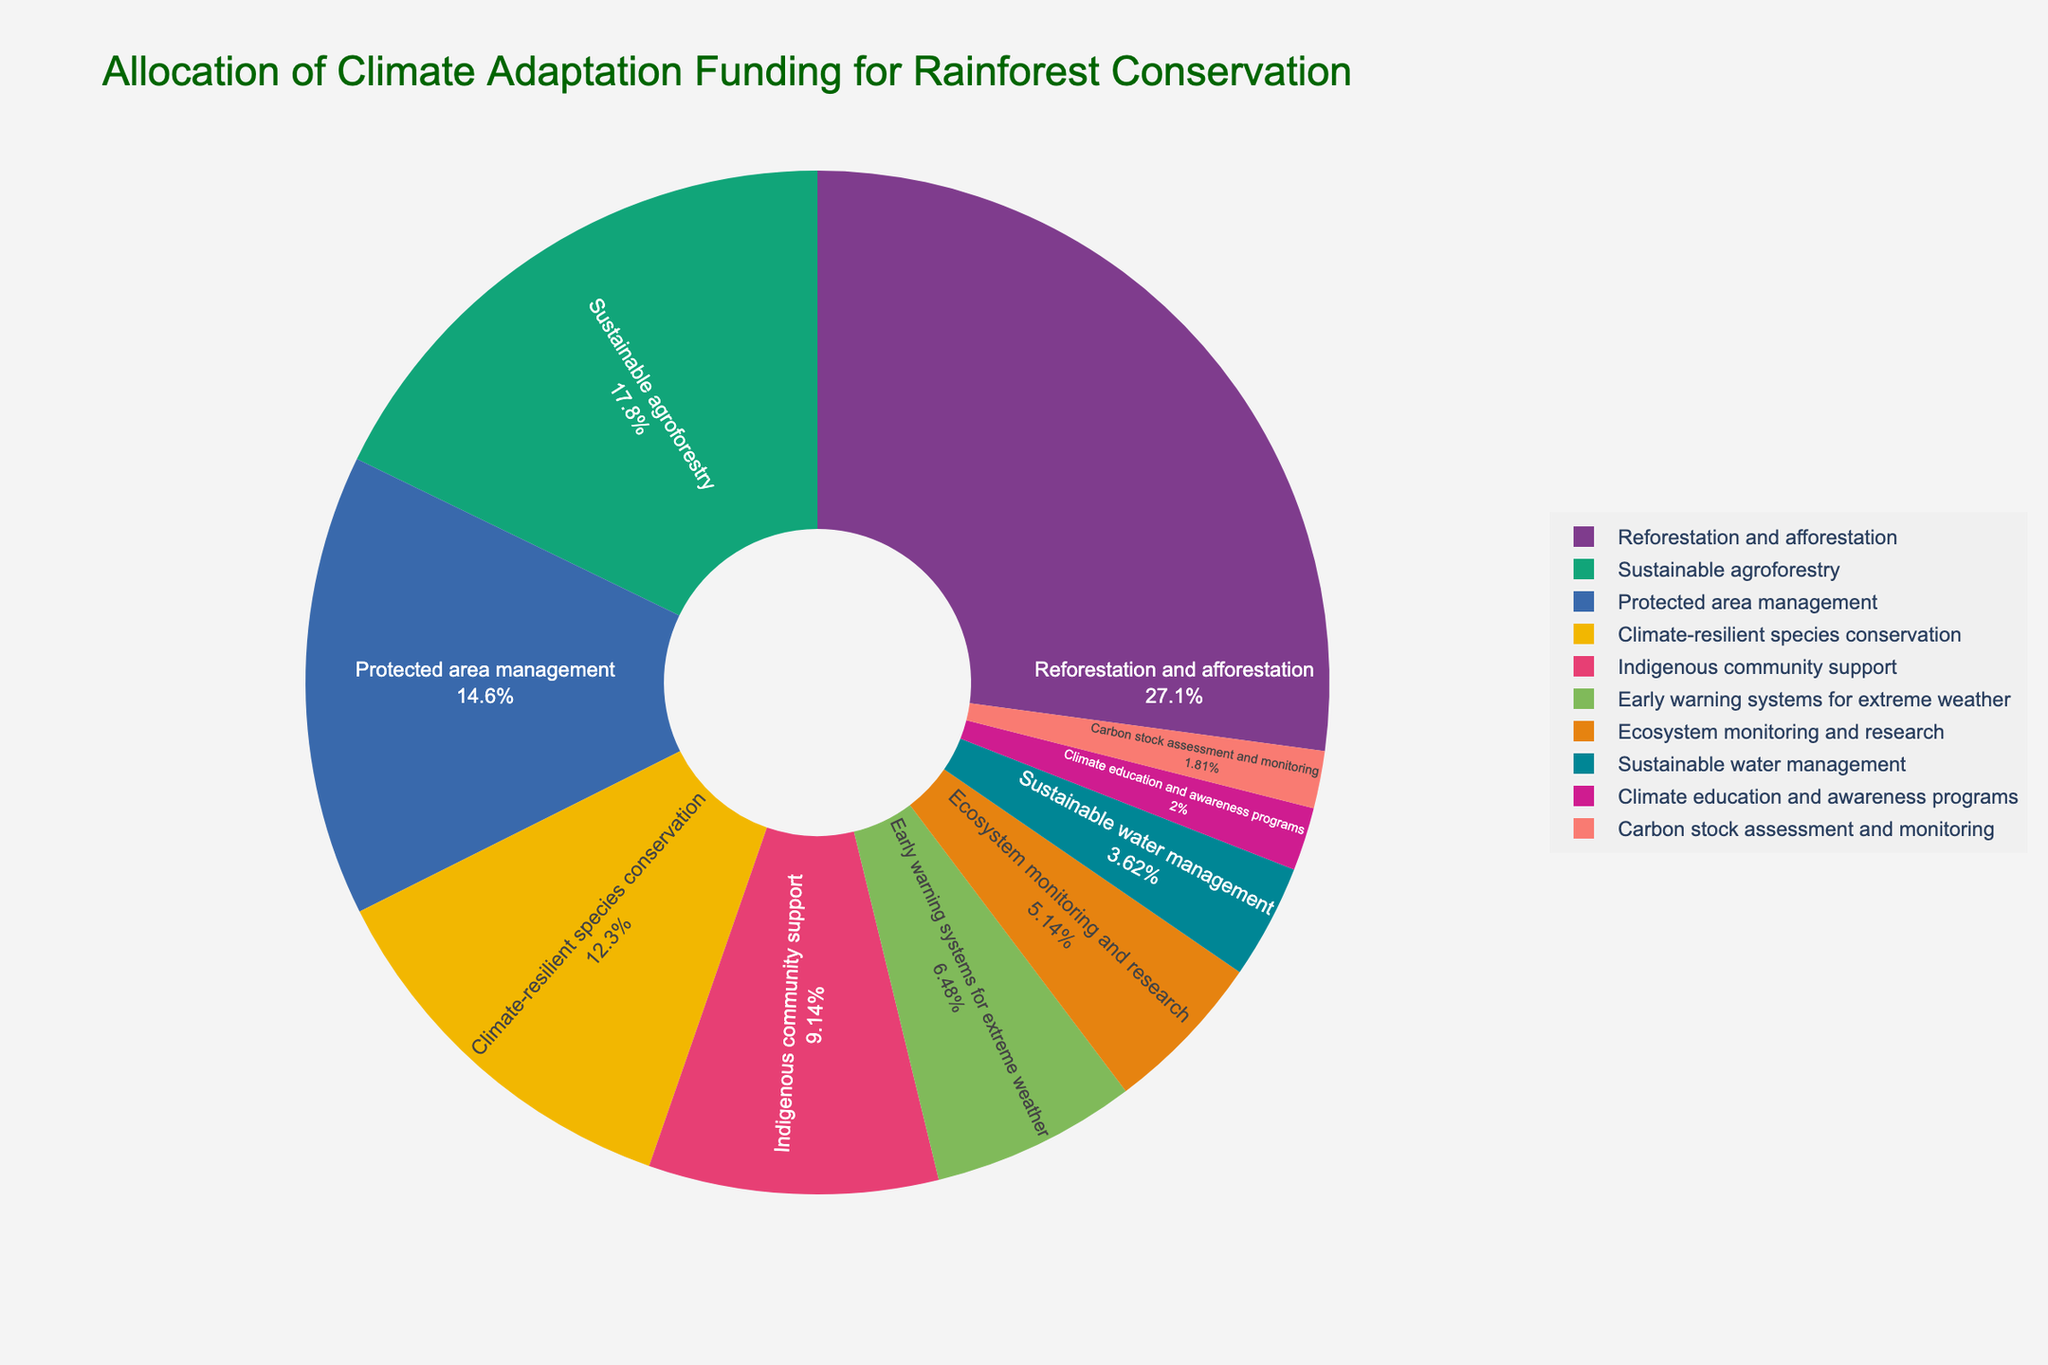How much funding is allocated to reforestation and afforestation compared to sustainable agroforestry? Reforestation and afforestation has an allocation of 28.5%, while sustainable agroforestry has 18.7%. The difference between them is 28.5% - 18.7% = 9.8%.
Answer: 9.8% What is the total funding allocated to protected area management, climate-resilient species conservation, and ecosystem monitoring and research combined? Adding the percentages for these strategies: 15.3 (protected area management) + 12.9 (climate-resilient species conservation) + 5.4 (ecosystem monitoring and research) = 33.6%.
Answer: 33.6% Which strategy received the least funding allocation and what is its allocation? Carbon stock assessment and monitoring received the least funding with an allocation of 1.9%.
Answer: Carbon stock assessment and monitoring, 1.9% Are there any strategies that received an equal funding allocation? No strategies have an equal funding allocation; all percentages are unique.
Answer: No What is the average funding allocation percentage for all strategies? Summing all allocations: 28.5 + 18.7 + 15.3 + 12.9 + 9.6 + 6.8 + 5.4 + 3.8 + 2.1 + 1.9 = 105%. Dividing by the number of strategies (10) gives an average of 105/10 = 10.5%.
Answer: 10.5% By how much does the funding for reforestation and afforestation exceed the funding for climate education and awareness programs? Reforestation and afforestation has 28.5%, while climate education and awareness programs have 2.1%. The difference is 28.5% - 2.1% = 26.4%.
Answer: 26.4% Which color represents sustainable agroforestry on the pie chart? Sustainable agroforestry is represented by the second color in the custom color palette used in the chart according to the Bold and Pastel palette combined, which would be a color from the Plotly Bold set. Without the specific colors listed, we cannot precisely identify it here.
Answer: Plotly Bold color If you were to allocate funding equally among all strategies, what would be the new funding percentage for each strategy? Equally dividing 100% by 10 strategies gives 100% / 10 = 10% per strategy.
Answer: 10% How does the funding for early warning systems for extreme weather compare with the funding for sustainable water management? Early warning systems for extreme weather received 6.8%, while sustainable water management received 3.8%. The difference is 6.8% - 3.8% = 3%.
Answer: 3% What is the cumulative funding for the three lowest funded strategies? Summing the allocations for the three lowest funded strategies: 2.1 (climate education and awareness programs) + 1.9 (carbon stock assessment and monitoring) + 3.8 (sustainable water management) = 7.8%.
Answer: 7.8% 